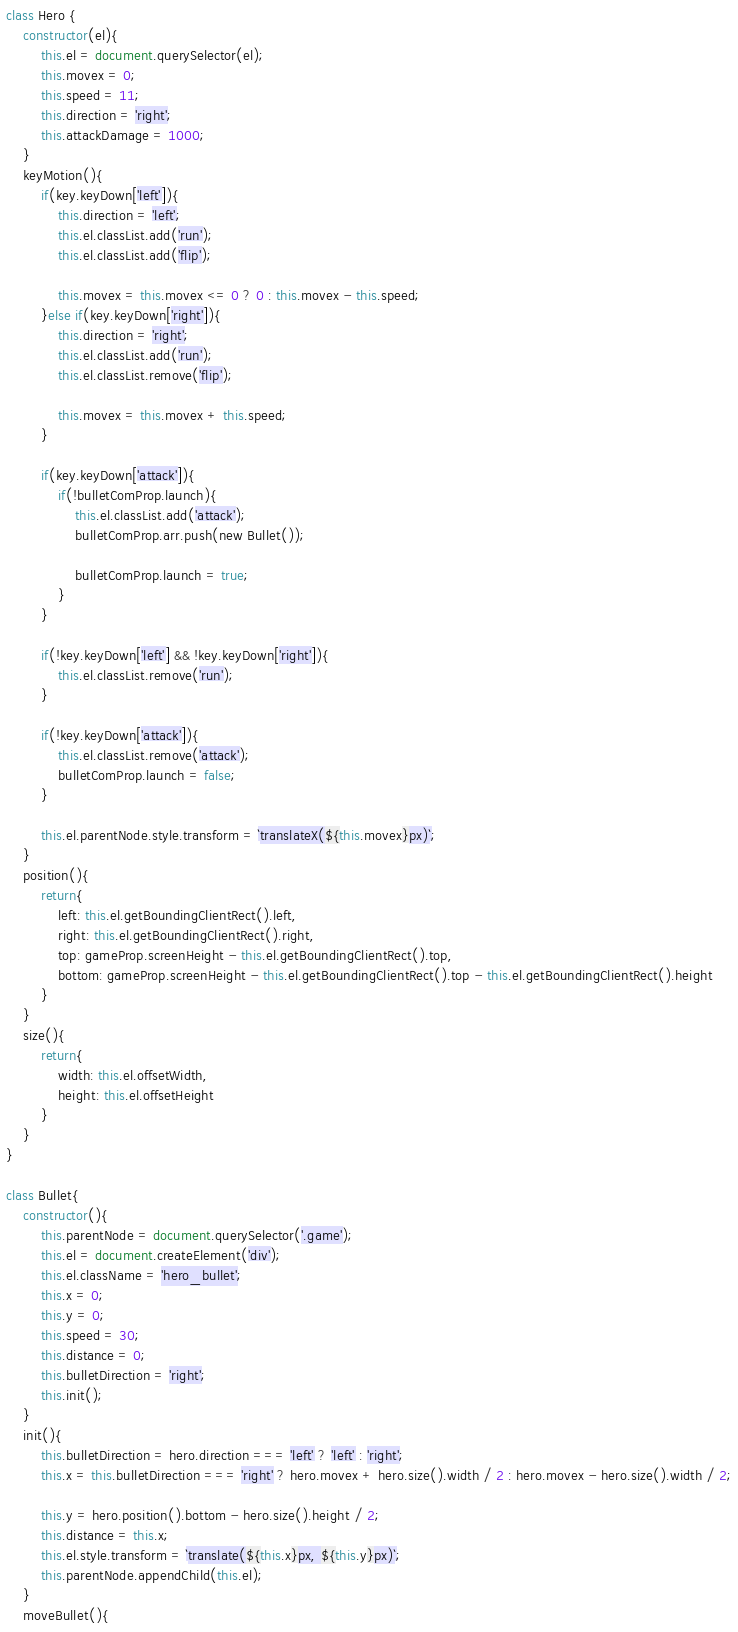Convert code to text. <code><loc_0><loc_0><loc_500><loc_500><_JavaScript_>class Hero {
	constructor(el){
		this.el = document.querySelector(el);
		this.movex = 0;
		this.speed = 11;
		this.direction = 'right';
		this.attackDamage = 1000;
	}
	keyMotion(){
		if(key.keyDown['left']){
			this.direction = 'left';
			this.el.classList.add('run');
			this.el.classList.add('flip');

			this.movex = this.movex <= 0 ? 0 : this.movex - this.speed;
		}else if(key.keyDown['right']){
			this.direction = 'right';
			this.el.classList.add('run');
			this.el.classList.remove('flip');

			this.movex = this.movex + this.speed;
		}

		if(key.keyDown['attack']){
			if(!bulletComProp.launch){
				this.el.classList.add('attack');
				bulletComProp.arr.push(new Bullet());

				bulletComProp.launch = true;
			}
		}

		if(!key.keyDown['left'] && !key.keyDown['right']){
			this.el.classList.remove('run');
		}

		if(!key.keyDown['attack']){
			this.el.classList.remove('attack');
			bulletComProp.launch = false;
		}

		this.el.parentNode.style.transform = `translateX(${this.movex}px)`;
	}
	position(){
		return{
			left: this.el.getBoundingClientRect().left,
			right: this.el.getBoundingClientRect().right,
			top: gameProp.screenHeight - this.el.getBoundingClientRect().top,
			bottom: gameProp.screenHeight - this.el.getBoundingClientRect().top - this.el.getBoundingClientRect().height
		}
	}
	size(){
		return{
			width: this.el.offsetWidth,
			height: this.el.offsetHeight
		}
	}
}

class Bullet{
	constructor(){
		this.parentNode = document.querySelector('.game');
		this.el = document.createElement('div');
		this.el.className = 'hero_bullet';
		this.x = 0;
		this.y = 0;
		this.speed = 30;
		this.distance = 0;
		this.bulletDirection = 'right';
		this.init();
	}
	init(){
		this.bulletDirection = hero.direction === 'left' ? 'left' : 'right';
		this.x = this.bulletDirection === 'right' ? hero.movex + hero.size().width / 2 : hero.movex - hero.size().width / 2;

		this.y = hero.position().bottom - hero.size().height / 2;
		this.distance = this.x;
		this.el.style.transform = `translate(${this.x}px, ${this.y}px)`;
		this.parentNode.appendChild(this.el);
	}
	moveBullet(){</code> 